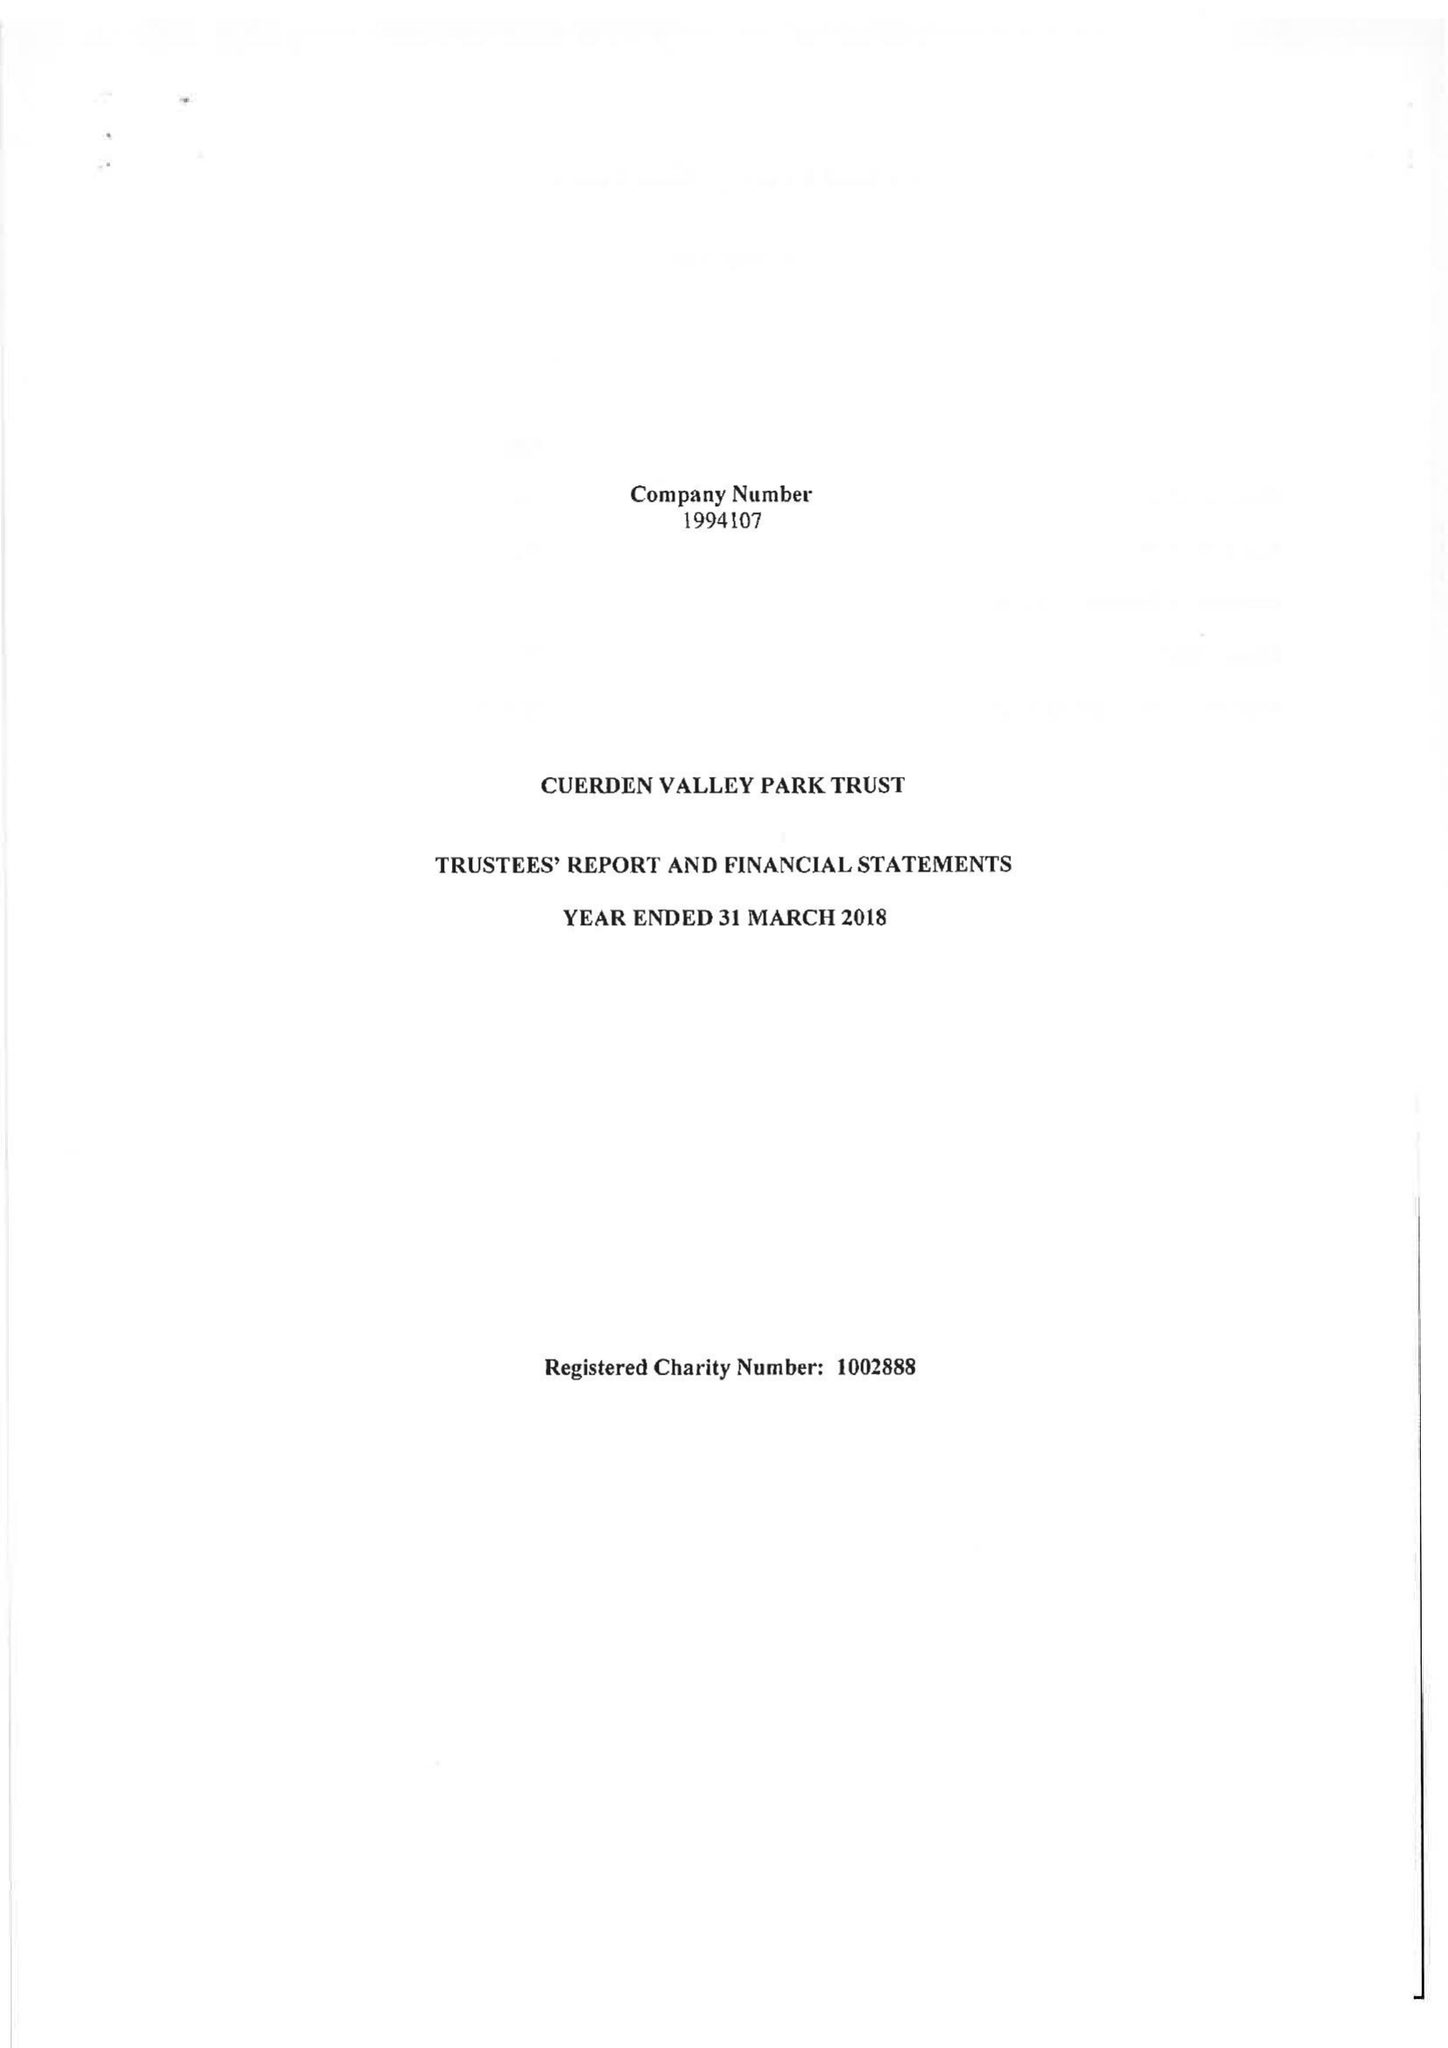What is the value for the spending_annually_in_british_pounds?
Answer the question using a single word or phrase. 280403.00 